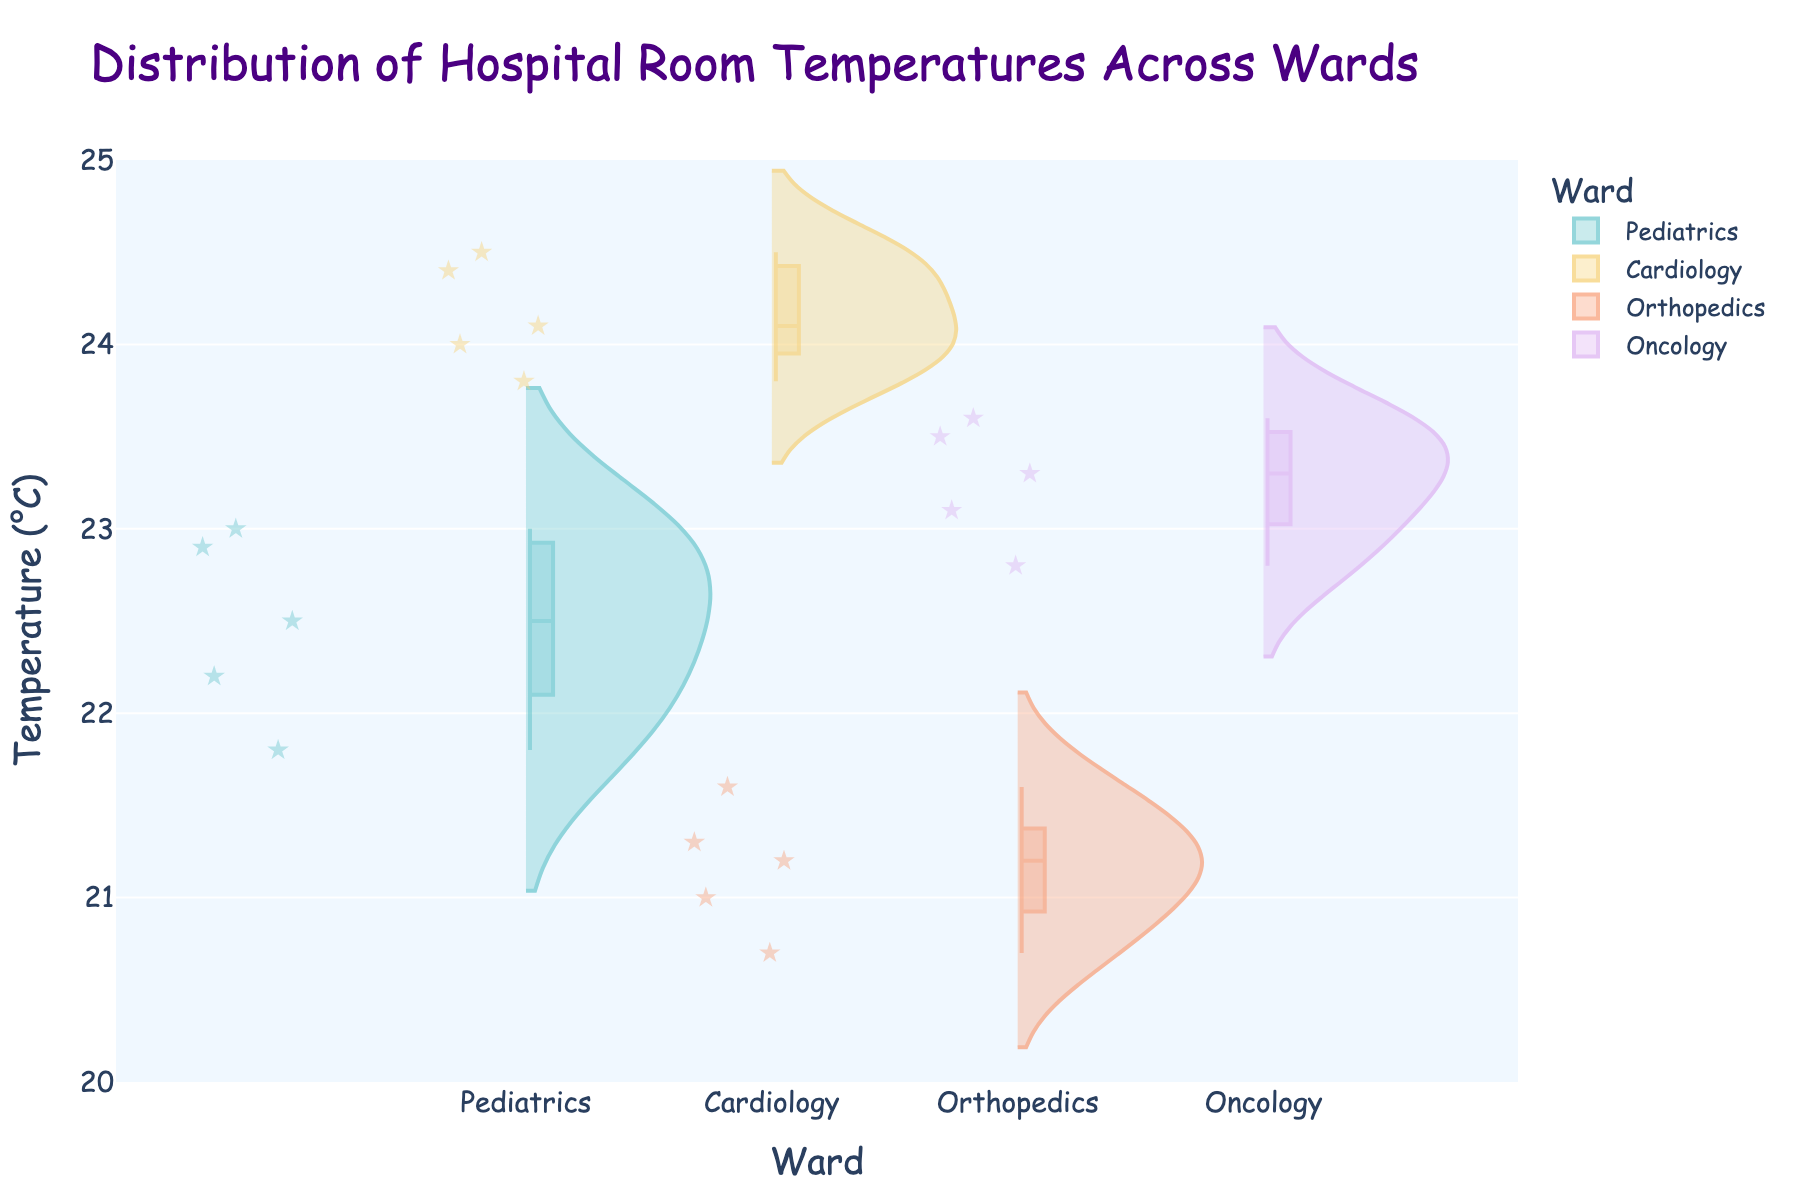Which ward has the highest median temperature? The median temperature is shown as the white dot within the violins. By visually inspecting the white dots, Cardiology has the highest median temperature.
Answer: Cardiology What is the range of temperatures in the Pediatrics ward? The range is determined by subtracting the lowest temperature from the highest temperature within the ward. For Pediatrics, the temperatures range from 21.8°C to 23.0°C, so the range is 23.0 - 21.8 = 1.2°C.
Answer: 1.2°C Which ward has the most variability in room temperatures? Variability can be seen from the width and spread of the violin plots. Cardiology shows the most variability as its violin plot is wider and more spread out compared to the others.
Answer: Cardiology What is the lowest room temperature recorded and in which ward? The lowest room temperature can be identified by the bottom point of the violins. Orthopedics has the lowest room temperature at 20.7°C.
Answer: Orthopedics Are there any wards where all room temperatures are above 23°C? By examining the lower bounds of the violins, it is clear that both Oncology and Cardiology have all room temperatures above 23°C.
Answer: Oncology and Cardiology What is the interquartile range (IQR) of temperatures for the Oncology ward? IQR is calculated by subtracting the 25th percentile (the bottom of the box) from the 75th percentile (the top of the box). For Oncology, these values can be visually estimated. (23.35°C - 23.1°C ≈ 0.25°C)
Answer: Approximately 0.25°C Which ward shows the least variability in room temperatures? The ward with the narrowest and least spread violin plot indicates the least variability. Pediatrics shows the least variability as its violin is the narrowest.
Answer: Pediatrics Comparing Pediatrics and Orthopedics, which has a higher median temperature? The median temperature is represented by the white dot within the violins. Comparing these, Pediatrics has a higher median temperature than Orthopedics.
Answer: Pediatrics How many wards have temperatures that go beyond 24°C? By inspecting the violins, Cardiology is the only ward with temperatures that exceed 24°C.
Answer: One (Cardiology) Which ward's room temperatures are most centered around a single value? The concentration of most points around a single value can be seen in the density of the violin. Pediatrics has room temperatures most concentrated around values near the center of its range (around 22.5°C).
Answer: Pediatrics 